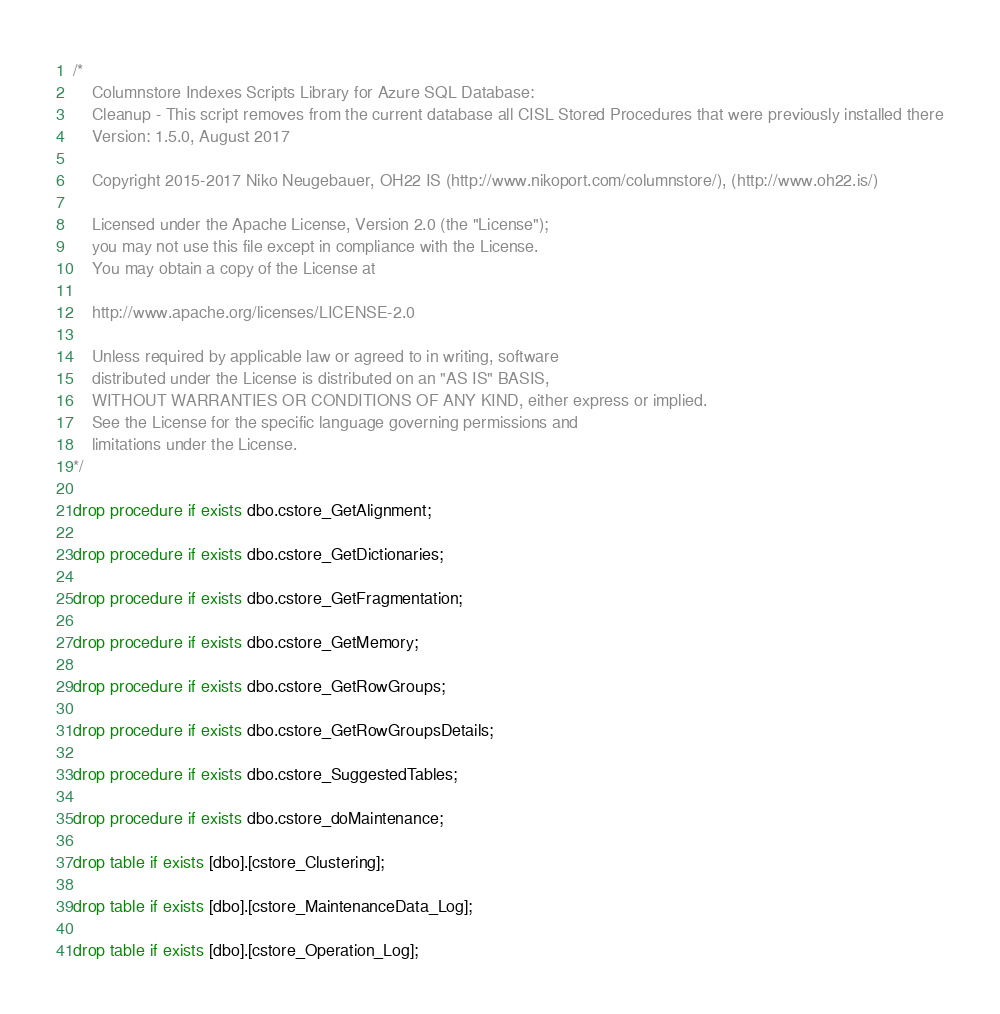<code> <loc_0><loc_0><loc_500><loc_500><_SQL_>/*
    Columnstore Indexes Scripts Library for Azure SQL Database: 
    Cleanup - This script removes from the current database all CISL Stored Procedures that were previously installed there
    Version: 1.5.0, August 2017

    Copyright 2015-2017 Niko Neugebauer, OH22 IS (http://www.nikoport.com/columnstore/), (http://www.oh22.is/)

    Licensed under the Apache License, Version 2.0 (the "License");
    you may not use this file except in compliance with the License.
    You may obtain a copy of the License at

    http://www.apache.org/licenses/LICENSE-2.0

    Unless required by applicable law or agreed to in writing, software
    distributed under the License is distributed on an "AS IS" BASIS,
    WITHOUT WARRANTIES OR CONDITIONS OF ANY KIND, either express or implied.
    See the License for the specific language governing permissions and
    limitations under the License.
*/

drop procedure if exists dbo.cstore_GetAlignment;

drop procedure if exists dbo.cstore_GetDictionaries;

drop procedure if exists dbo.cstore_GetFragmentation;

drop procedure if exists dbo.cstore_GetMemory;

drop procedure if exists dbo.cstore_GetRowGroups;

drop procedure if exists dbo.cstore_GetRowGroupsDetails;

drop procedure if exists dbo.cstore_SuggestedTables;

drop procedure if exists dbo.cstore_doMaintenance;

drop table if exists [dbo].[cstore_Clustering];

drop table if exists [dbo].[cstore_MaintenanceData_Log];

drop table if exists [dbo].[cstore_Operation_Log];</code> 